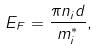Convert formula to latex. <formula><loc_0><loc_0><loc_500><loc_500>E _ { F } = { \frac { \pi n _ { i } d } { { m _ { i } ^ { \ast } } } } ,</formula> 